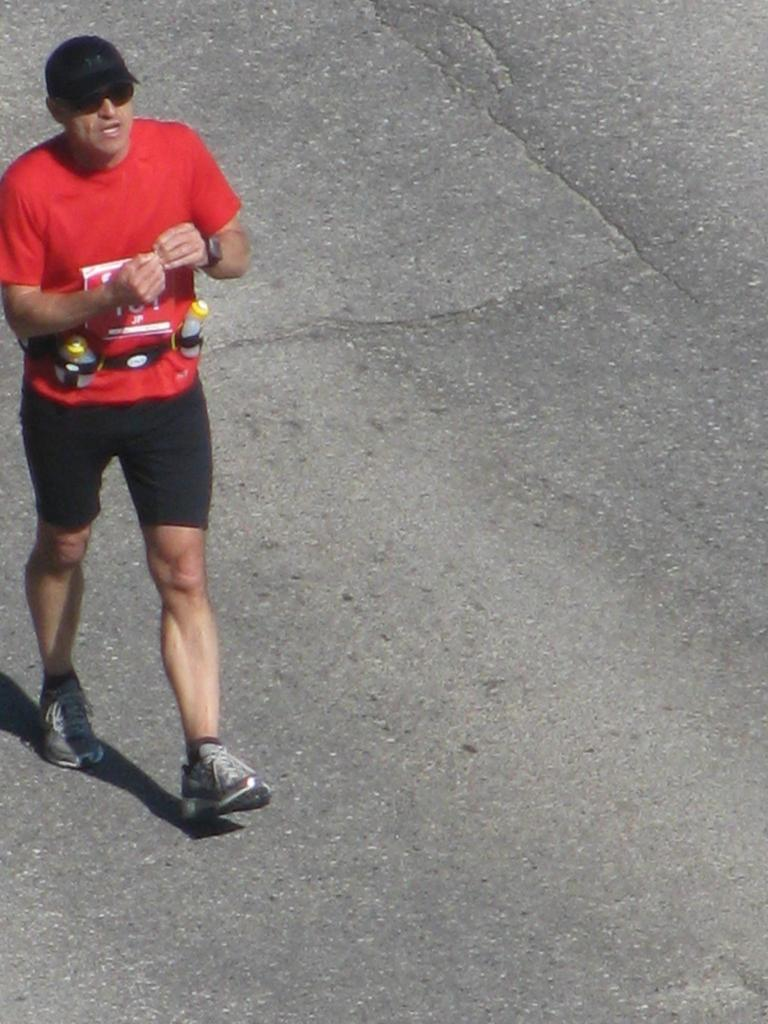What is the main subject of the image? There is a man walking in the image. What can be seen in the background of the image? There is a road visible in the background of the image. How many donkeys are present in the image? There are no donkeys present in the image. What type of bird can be seen flying in the image? There are no birds visible in the image. 